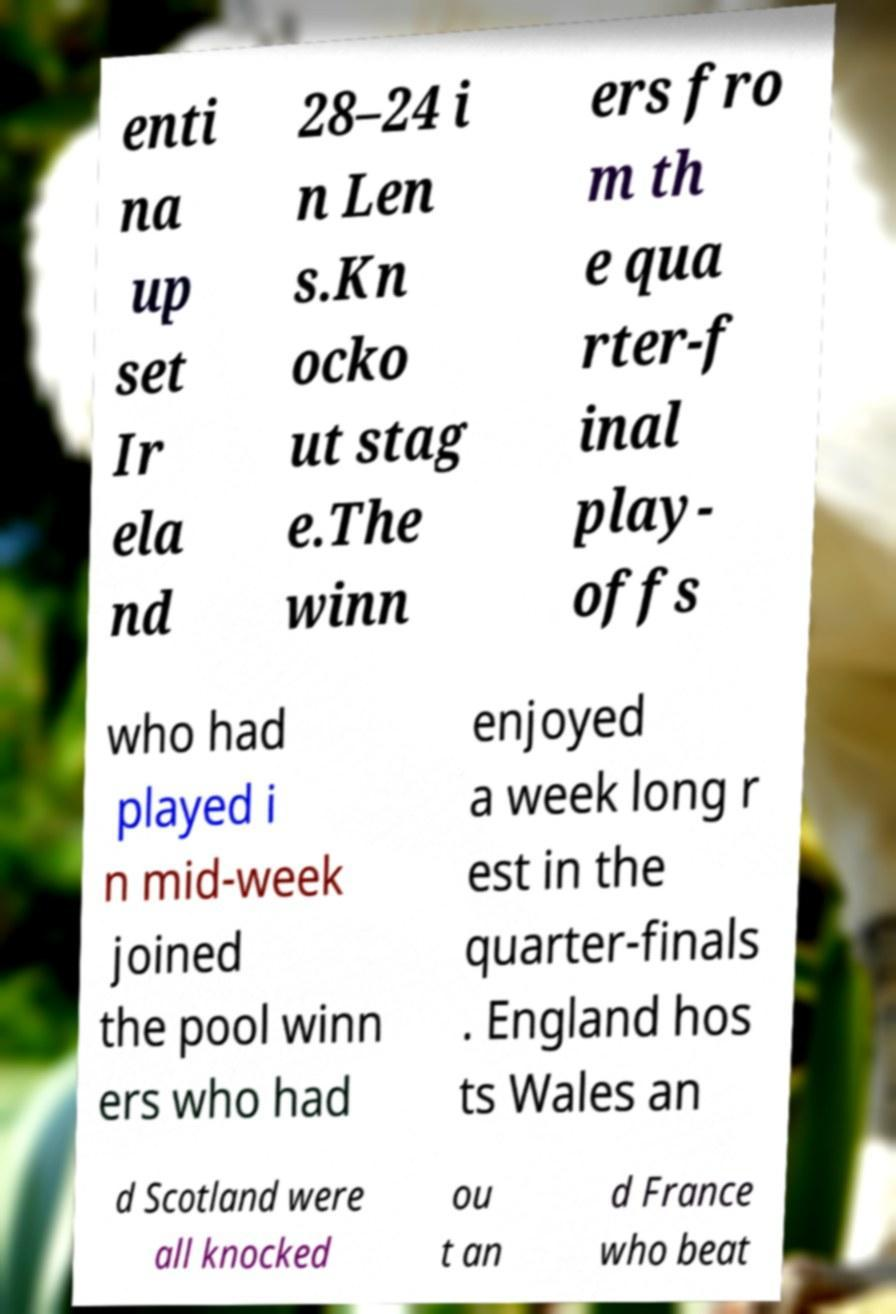Could you extract and type out the text from this image? enti na up set Ir ela nd 28–24 i n Len s.Kn ocko ut stag e.The winn ers fro m th e qua rter-f inal play- offs who had played i n mid-week joined the pool winn ers who had enjoyed a week long r est in the quarter-finals . England hos ts Wales an d Scotland were all knocked ou t an d France who beat 